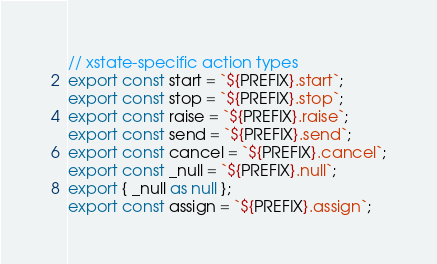Convert code to text. <code><loc_0><loc_0><loc_500><loc_500><_TypeScript_>
// xstate-specific action types
export const start = `${PREFIX}.start`;
export const stop = `${PREFIX}.stop`;
export const raise = `${PREFIX}.raise`;
export const send = `${PREFIX}.send`;
export const cancel = `${PREFIX}.cancel`;
export const _null = `${PREFIX}.null`;
export { _null as null };
export const assign = `${PREFIX}.assign`;


</code> 